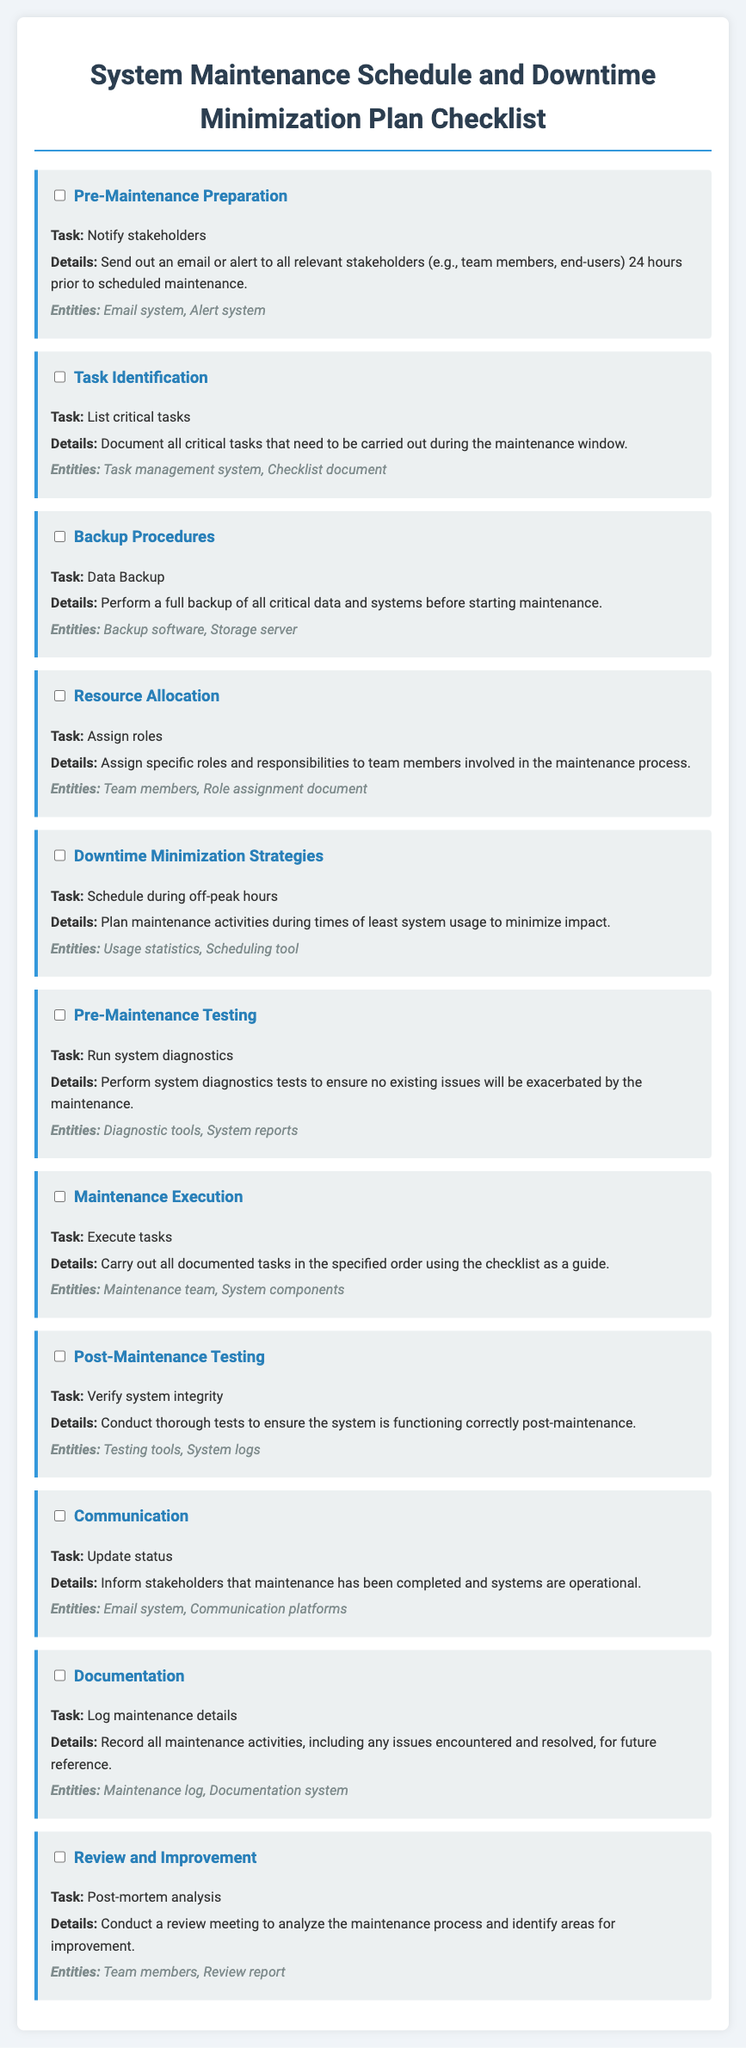What is the first task listed? The first task is "Notify stakeholders," which is mentioned under the "Pre-Maintenance Preparation" section.
Answer: Notify stakeholders What is the task under Backup Procedures? The task listed under Backup Procedures is "Data Backup."
Answer: Data Backup What should be verified during Post-Maintenance Testing? The verification during Post-Maintenance Testing involves checking "system integrity."
Answer: system integrity How many main parts are there in the checklist? There are ten main parts listed in the checklist, each representing a different task.
Answer: 10 What is the focus of the Review and Improvement section? The focus is on conducting a "post-mortem analysis" to evaluate the maintenance process.
Answer: post-mortem analysis What role is assigned during Resource Allocation? The role assigned during Resource Allocation is to "Assign roles" to team members involved in maintenance.
Answer: Assign roles When should maintenance activities be scheduled? Maintenance activities should be scheduled during "off-peak hours" to minimize impact.
Answer: off-peak hours Which system should be updated after completing maintenance? The "Email system" should be used to update stakeholders regarding the maintenance completion.
Answer: Email system 